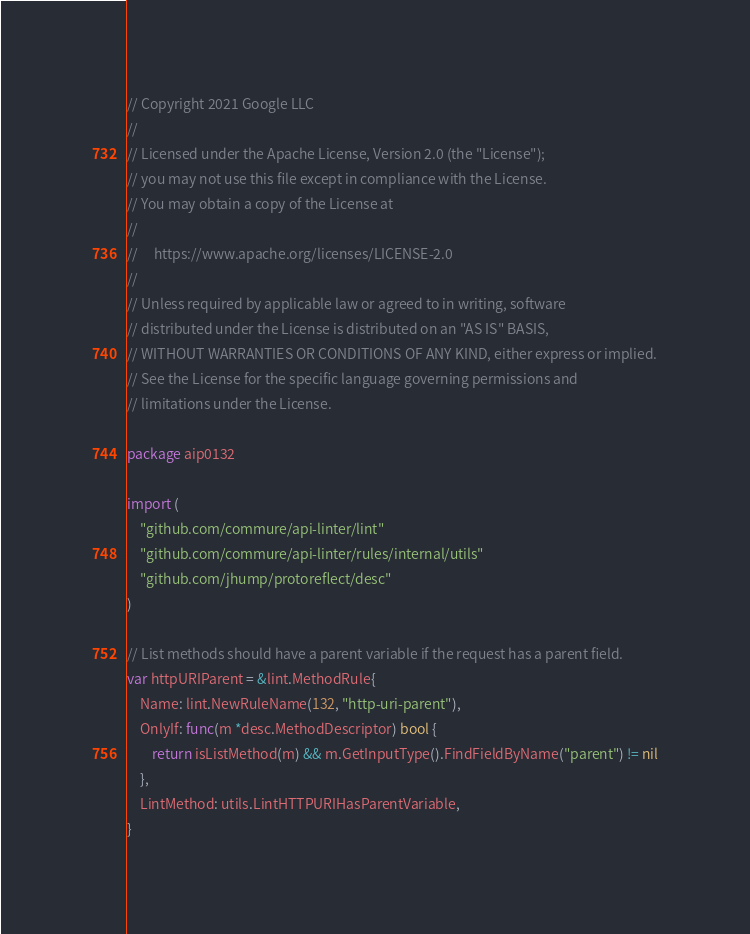<code> <loc_0><loc_0><loc_500><loc_500><_Go_>// Copyright 2021 Google LLC
//
// Licensed under the Apache License, Version 2.0 (the "License");
// you may not use this file except in compliance with the License.
// You may obtain a copy of the License at
//
//     https://www.apache.org/licenses/LICENSE-2.0
//
// Unless required by applicable law or agreed to in writing, software
// distributed under the License is distributed on an "AS IS" BASIS,
// WITHOUT WARRANTIES OR CONDITIONS OF ANY KIND, either express or implied.
// See the License for the specific language governing permissions and
// limitations under the License.

package aip0132

import (
	"github.com/commure/api-linter/lint"
	"github.com/commure/api-linter/rules/internal/utils"
	"github.com/jhump/protoreflect/desc"
)

// List methods should have a parent variable if the request has a parent field.
var httpURIParent = &lint.MethodRule{
	Name: lint.NewRuleName(132, "http-uri-parent"),
	OnlyIf: func(m *desc.MethodDescriptor) bool {
		return isListMethod(m) && m.GetInputType().FindFieldByName("parent") != nil
	},
	LintMethod: utils.LintHTTPURIHasParentVariable,
}
</code> 